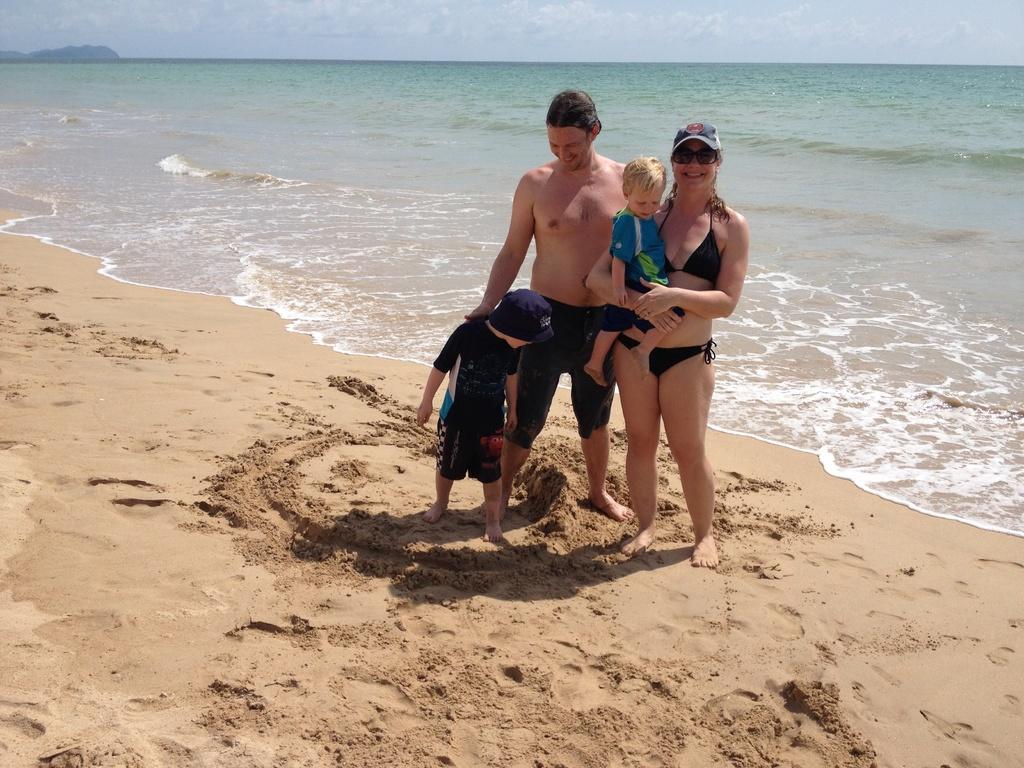Can you describe this image briefly? In this picture I can see a man, woman and a kid standing and I can see woman holding a baby. I can see water and a cloudy sky and woman wearing a cap and sunglasses and I can see a boy wearing cap on his head. 